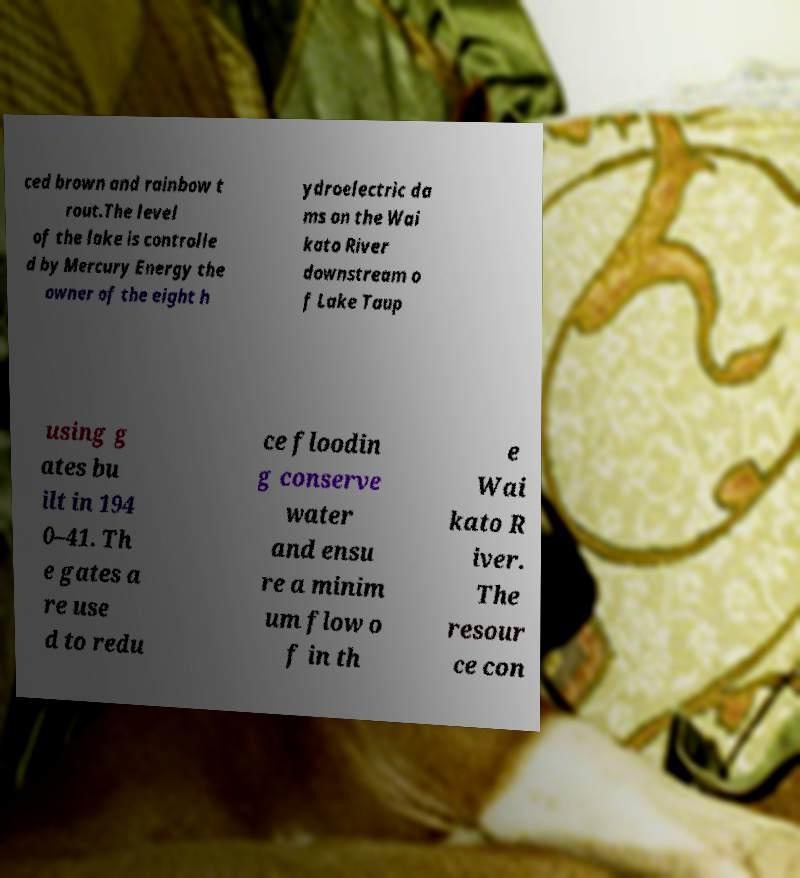For documentation purposes, I need the text within this image transcribed. Could you provide that? ced brown and rainbow t rout.The level of the lake is controlle d by Mercury Energy the owner of the eight h ydroelectric da ms on the Wai kato River downstream o f Lake Taup using g ates bu ilt in 194 0–41. Th e gates a re use d to redu ce floodin g conserve water and ensu re a minim um flow o f in th e Wai kato R iver. The resour ce con 